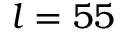<formula> <loc_0><loc_0><loc_500><loc_500>l = 5 5</formula> 